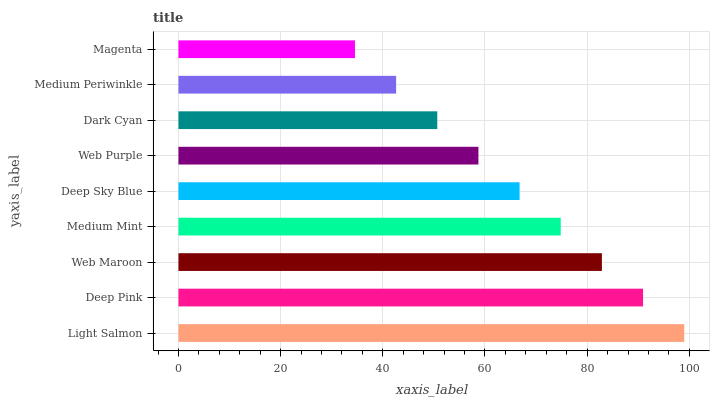Is Magenta the minimum?
Answer yes or no. Yes. Is Light Salmon the maximum?
Answer yes or no. Yes. Is Deep Pink the minimum?
Answer yes or no. No. Is Deep Pink the maximum?
Answer yes or no. No. Is Light Salmon greater than Deep Pink?
Answer yes or no. Yes. Is Deep Pink less than Light Salmon?
Answer yes or no. Yes. Is Deep Pink greater than Light Salmon?
Answer yes or no. No. Is Light Salmon less than Deep Pink?
Answer yes or no. No. Is Deep Sky Blue the high median?
Answer yes or no. Yes. Is Deep Sky Blue the low median?
Answer yes or no. Yes. Is Web Purple the high median?
Answer yes or no. No. Is Deep Pink the low median?
Answer yes or no. No. 